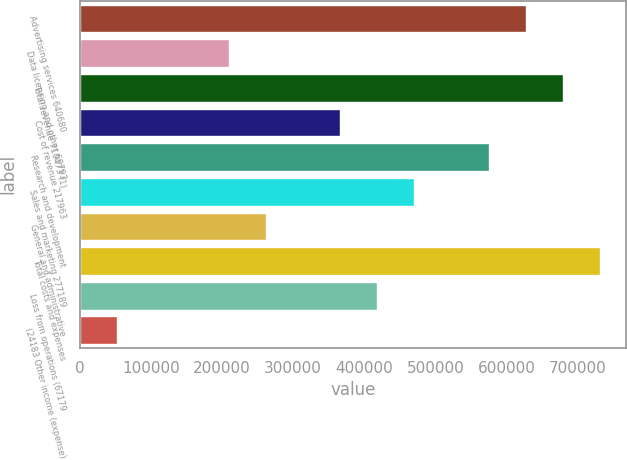<chart> <loc_0><loc_0><loc_500><loc_500><bar_chart><fcel>Advertising services 640680<fcel>Data licensing and other 69793<fcel>Total revenue 710473 (1)<fcel>Cost of revenue 217963<fcel>Research and development<fcel>Sales and marketing 277189<fcel>General and administrative<fcel>Total costs and expenses<fcel>Loss from operations (67179<fcel>(24183 Other income (expense)<nl><fcel>627236<fcel>209079<fcel>679506<fcel>365888<fcel>574967<fcel>470427<fcel>261349<fcel>731776<fcel>418158<fcel>52270<nl></chart> 